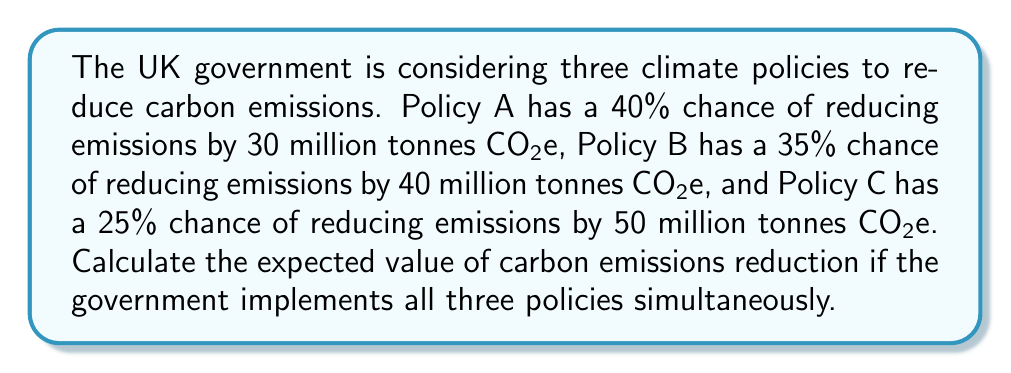Show me your answer to this math problem. To solve this problem, we need to calculate the expected value of carbon emissions reduction for each policy and then sum them up. The expected value is calculated by multiplying the probability of each outcome by its corresponding value.

1. For Policy A:
   $E(A) = 0.40 \times 30 = 12$ million tonnes CO2e

2. For Policy B:
   $E(B) = 0.35 \times 40 = 14$ million tonnes CO2e

3. For Policy C:
   $E(C) = 0.25 \times 50 = 12.5$ million tonnes CO2e

4. The total expected value is the sum of the individual expected values:
   $E(total) = E(A) + E(B) + E(C)$
   $E(total) = 12 + 14 + 12.5 = 38.5$ million tonnes CO2e

Therefore, the expected value of carbon emissions reduction if the government implements all three policies simultaneously is 38.5 million tonnes CO2e.
Answer: 38.5 million tonnes CO2e 